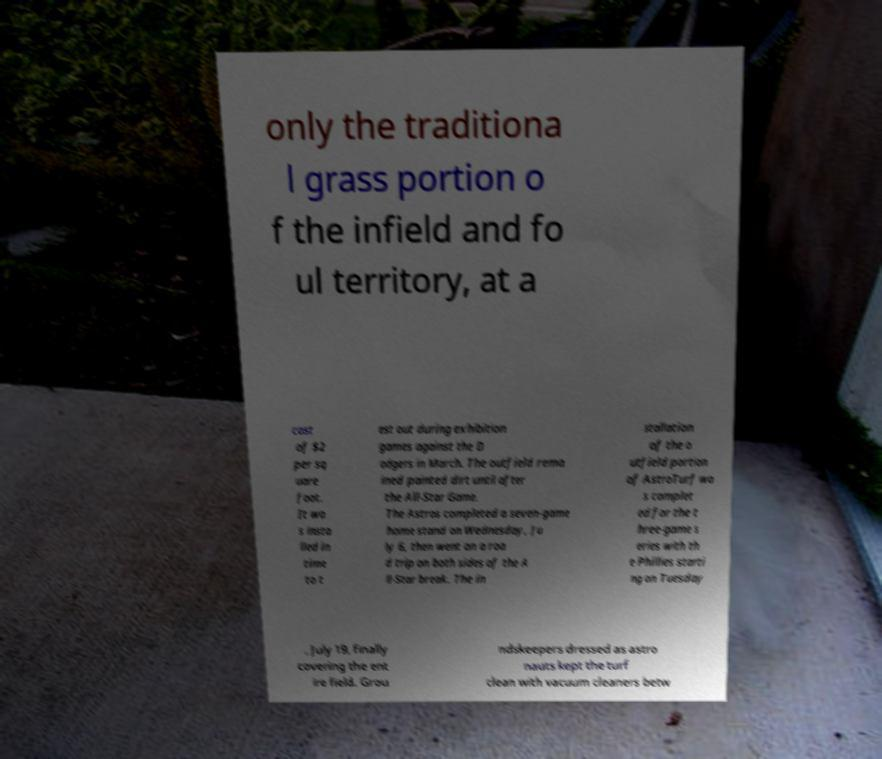Can you accurately transcribe the text from the provided image for me? only the traditiona l grass portion o f the infield and fo ul territory, at a cost of $2 per sq uare foot. It wa s insta lled in time to t est out during exhibition games against the D odgers in March. The outfield rema ined painted dirt until after the All-Star Game. The Astros completed a seven-game home stand on Wednesday, Ju ly 6, then went on a roa d trip on both sides of the A ll-Star break. The in stallation of the o utfield portion of AstroTurf wa s complet ed for the t hree-game s eries with th e Phillies starti ng on Tuesday , July 19, finally covering the ent ire field. Grou ndskeepers dressed as astro nauts kept the turf clean with vacuum cleaners betw 